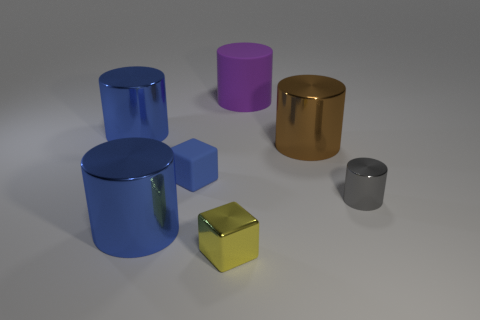What number of other cylinders have the same material as the gray cylinder?
Offer a very short reply. 3. What number of things are either large cylinders in front of the tiny blue block or blue matte cubes?
Your answer should be compact. 2. How big is the brown shiny cylinder?
Offer a very short reply. Large. What material is the blue cylinder in front of the blue shiny cylinder behind the gray metal cylinder made of?
Your answer should be very brief. Metal. There is a rubber thing that is left of the yellow cube; is its size the same as the yellow block?
Provide a short and direct response. Yes. Are there any cylinders that have the same color as the small matte object?
Provide a short and direct response. Yes. What number of objects are metal objects that are behind the yellow thing or big blue things that are behind the small blue rubber cube?
Your answer should be very brief. 4. Does the big matte object have the same color as the small shiny cube?
Ensure brevity in your answer.  No. Is the number of tiny blue rubber objects that are on the right side of the tiny rubber block less than the number of brown things that are behind the large matte cylinder?
Provide a short and direct response. No. Is the tiny blue cube made of the same material as the tiny gray cylinder?
Provide a succinct answer. No. 